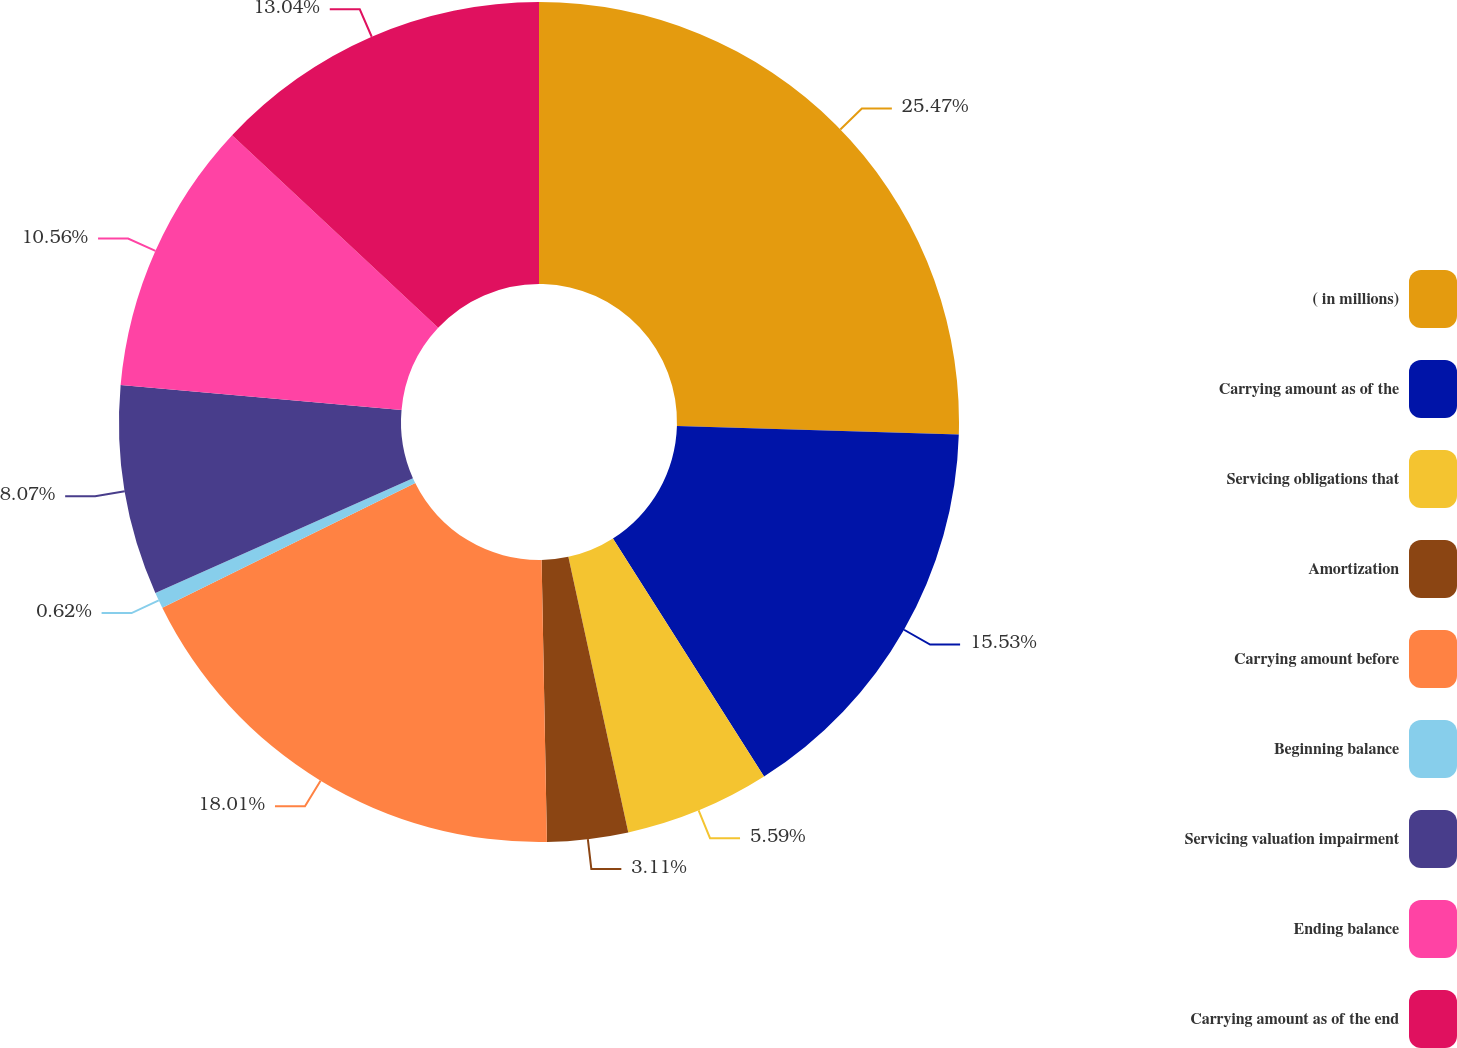Convert chart to OTSL. <chart><loc_0><loc_0><loc_500><loc_500><pie_chart><fcel>( in millions)<fcel>Carrying amount as of the<fcel>Servicing obligations that<fcel>Amortization<fcel>Carrying amount before<fcel>Beginning balance<fcel>Servicing valuation impairment<fcel>Ending balance<fcel>Carrying amount as of the end<nl><fcel>25.47%<fcel>15.53%<fcel>5.59%<fcel>3.11%<fcel>18.01%<fcel>0.62%<fcel>8.07%<fcel>10.56%<fcel>13.04%<nl></chart> 